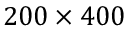<formula> <loc_0><loc_0><loc_500><loc_500>2 0 0 \times 4 0 0</formula> 